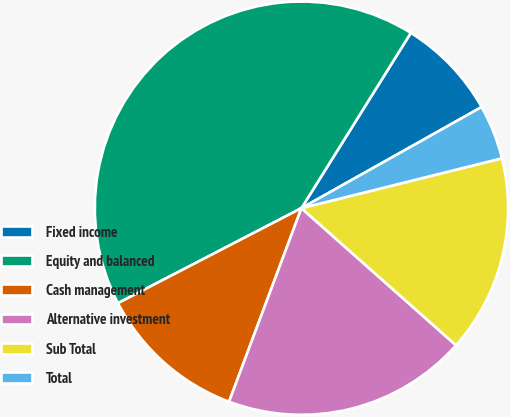Convert chart. <chart><loc_0><loc_0><loc_500><loc_500><pie_chart><fcel>Fixed income<fcel>Equity and balanced<fcel>Cash management<fcel>Alternative investment<fcel>Sub Total<fcel>Total<nl><fcel>7.98%<fcel>41.49%<fcel>11.7%<fcel>19.15%<fcel>15.43%<fcel>4.26%<nl></chart> 